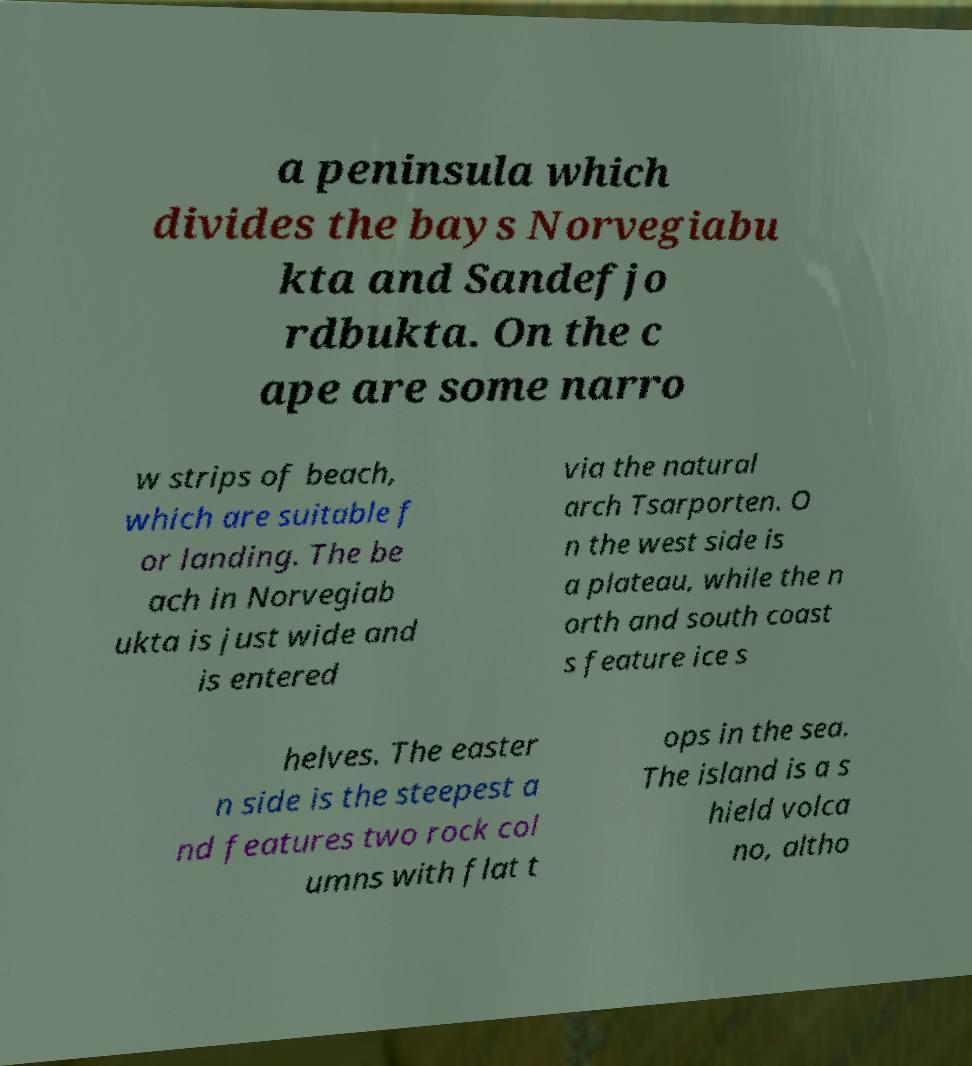I need the written content from this picture converted into text. Can you do that? a peninsula which divides the bays Norvegiabu kta and Sandefjo rdbukta. On the c ape are some narro w strips of beach, which are suitable f or landing. The be ach in Norvegiab ukta is just wide and is entered via the natural arch Tsarporten. O n the west side is a plateau, while the n orth and south coast s feature ice s helves. The easter n side is the steepest a nd features two rock col umns with flat t ops in the sea. The island is a s hield volca no, altho 